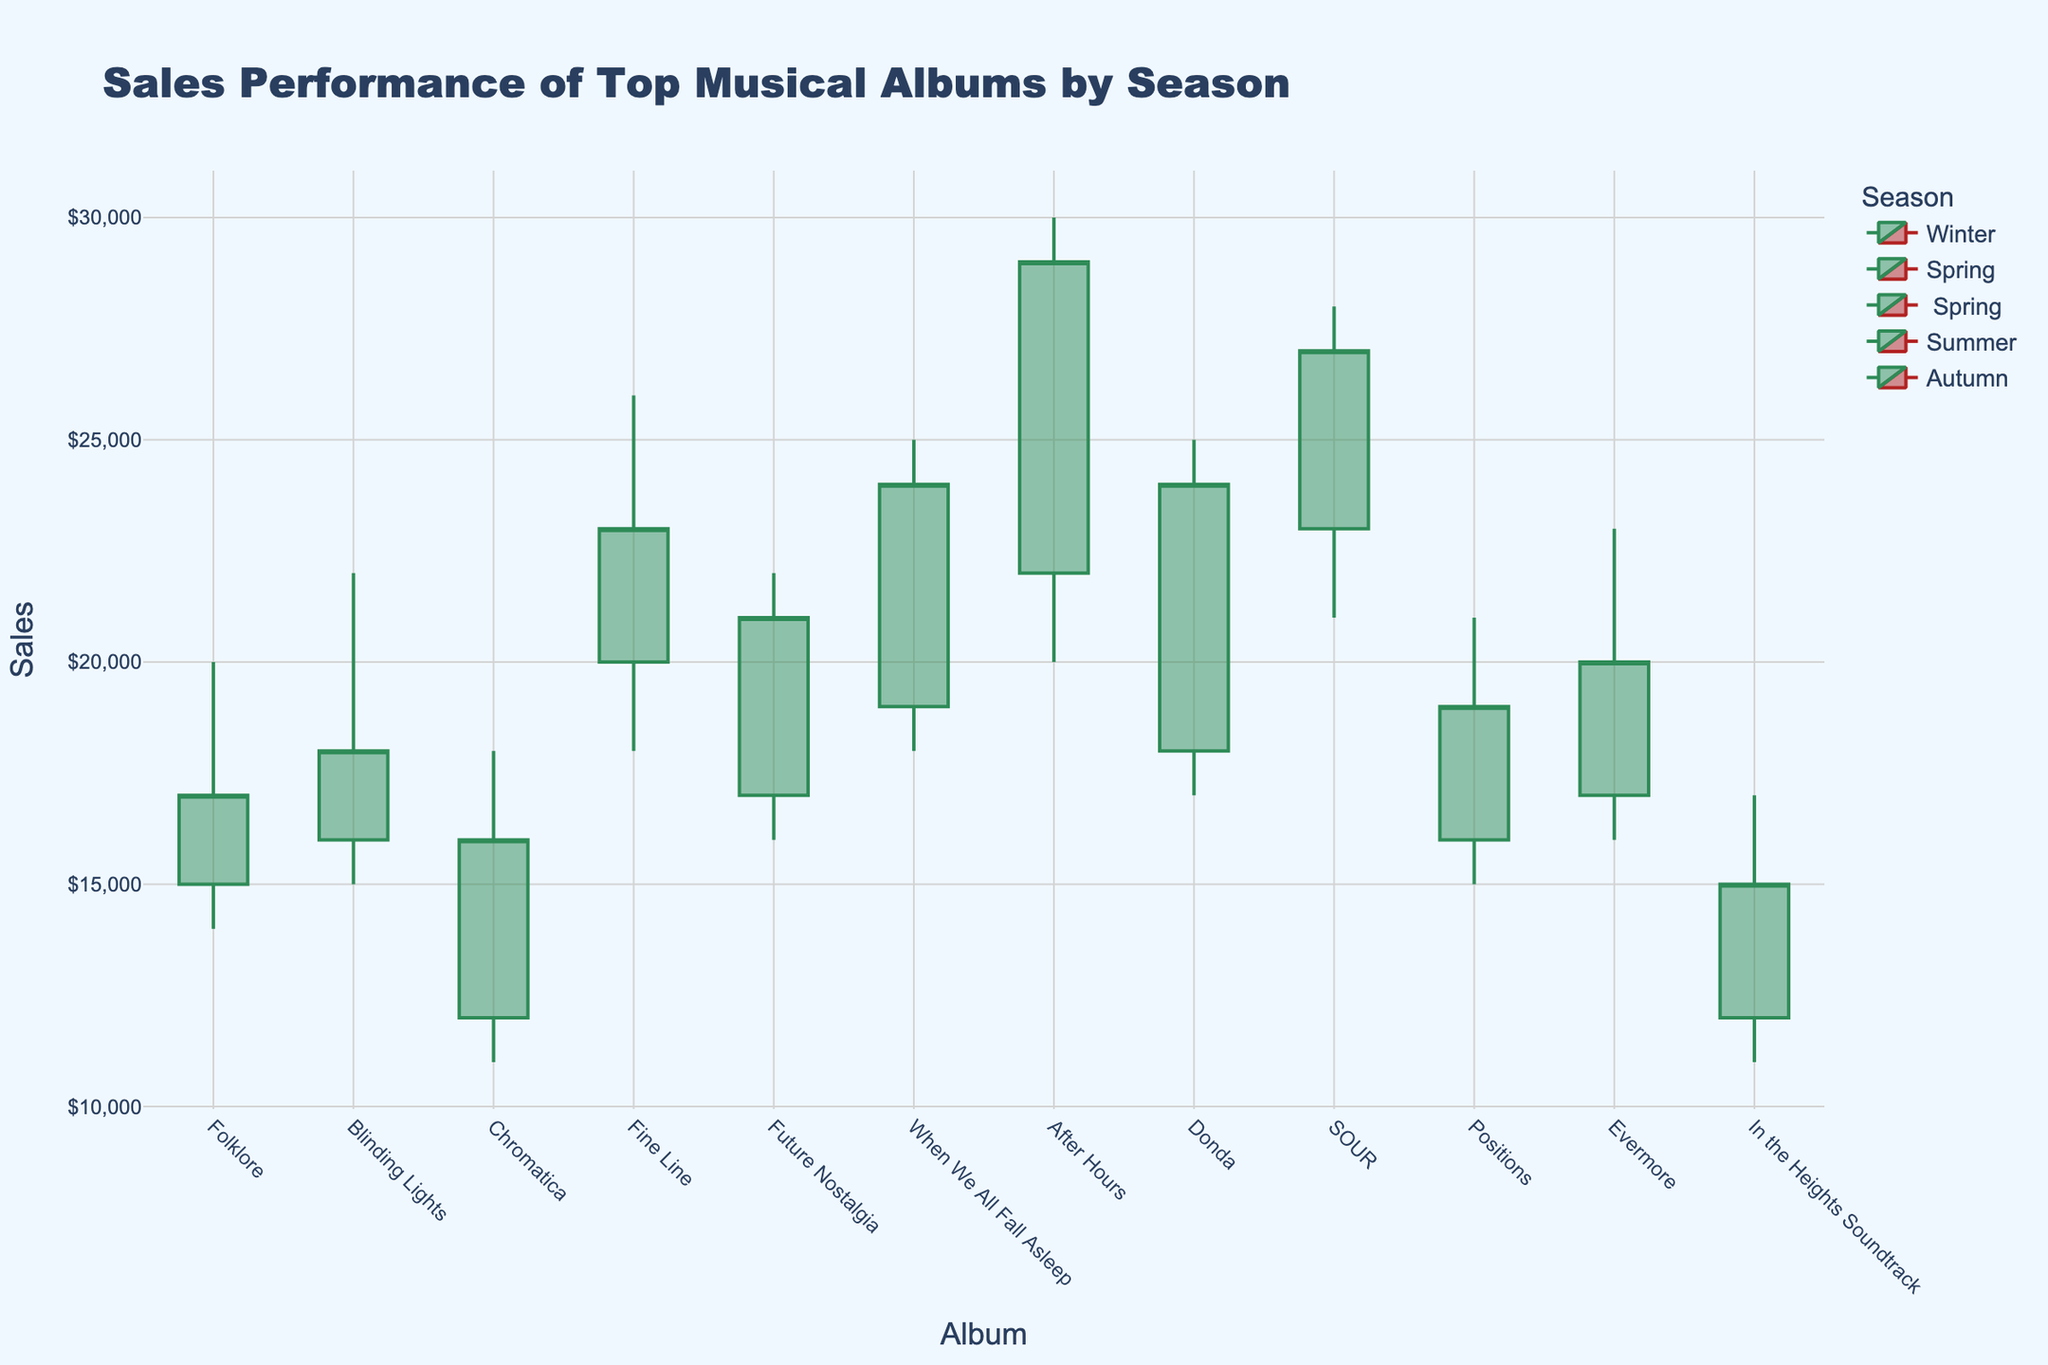What is the title of the candlestick plot? The title is usually prominently displayed at the top of the plot and it's meant to succinctly describe what the chart is about. In this case, the title is "Sales Performance of Top Musical Albums by Season," as it summarizes the main focus of the graph, which is sales performance segmented by seasons.
Answer: Sales Performance of Top Musical Albums by Season How many albums are represented in the Winter season? To find the number of albums, you can identify the number of candlesticks with the color representing Winter. Each album name will be listed at the x-axis and each has a corresponding candlestick. By referring to the figure, we see there are three: "Folklore," "Blinding Lights," and "Chromatica."
Answer: 3 Which album had the highest sales point in the Summer season? Look for the highest peak among the candlesticks labeled for the Summer season. In this case, "After Hours" has the highest point at 30,000, which is the highest value in the Summer season candlestick data.
Answer: After Hours What is the range of the "When We All Fall Asleep" album sales in the Spring season? The range is calculated by the difference between the highest and lowest sales points of the album. For "When We All Fall Asleep," the highest point is 25,000 and the lowest is 18,000. Hence, the range is 25,000 - 18,000.
Answer: 7,000 Which album experienced an increase in sales from the low to the close value in the Autumn season? Examine the candlesticks for the Autumn season albums and identify which ones close higher than their low values. "Positions," "Evermore," and "In the Heights Soundtrack" have closing values higher than their respective low values.
Answer: Positions, Evermore, In the Heights Soundtrack What is the closing value of "Future Nostalgia" in the Spring season? The closing value is the final price at the end of the period examined. For "Future Nostalgia" during the Spring season, the closing value, indicated by the x-axis label, is 21,000.
Answer: 21,000 Compare the highest sales point of "Donda" in Summer with "Positions" in Autumn. Locate the highest sales points of each album. "Donda" in the Summer has a high value of 25,000, while "Positions" in Autumn has a high value of 21,000. Compare these two values to determine which one is higher.
Answer: Donda's highest sales point is higher than Positions' Which season has the album with the lowest closing value? Identify the closing values across all candlesticks and find the lowest one. The lowest closing value among all seasons is for "In the Heights Soundtrack" in the Autumn season, with a closing value of 15,000.
Answer: Autumn Calculate the average opening sales value for albums in the Spring season. The albums in the Spring season have opening values of 20,000, 17,000, and 19,000. Sum these values (20,000 + 17,000 + 19,000 = 56,000) and divide by the number of values (3) to get the average.
Answer: 18,667 